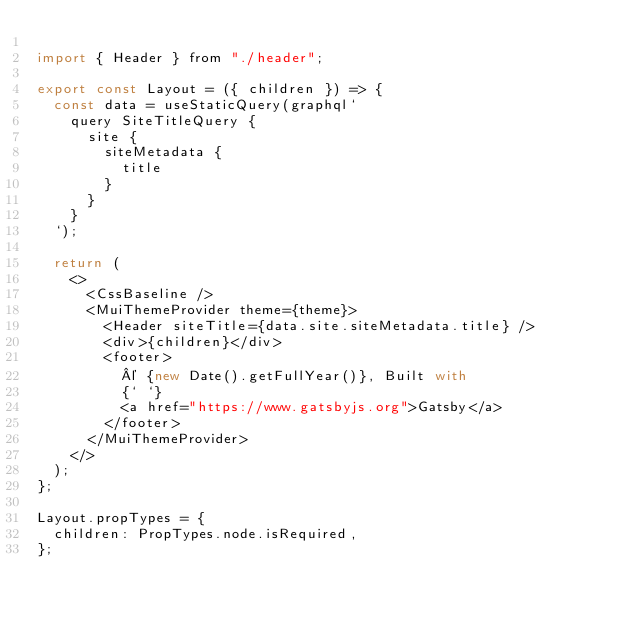<code> <loc_0><loc_0><loc_500><loc_500><_JavaScript_>
import { Header } from "./header";

export const Layout = ({ children }) => {
  const data = useStaticQuery(graphql`
    query SiteTitleQuery {
      site {
        siteMetadata {
          title
        }
      }
    }
  `);

  return (
    <>
      <CssBaseline />
      <MuiThemeProvider theme={theme}>
        <Header siteTitle={data.site.siteMetadata.title} />
        <div>{children}</div>
        <footer>
          © {new Date().getFullYear()}, Built with
          {` `}
          <a href="https://www.gatsbyjs.org">Gatsby</a>
        </footer>
      </MuiThemeProvider>
    </>
  );
};

Layout.propTypes = {
  children: PropTypes.node.isRequired,
};
</code> 